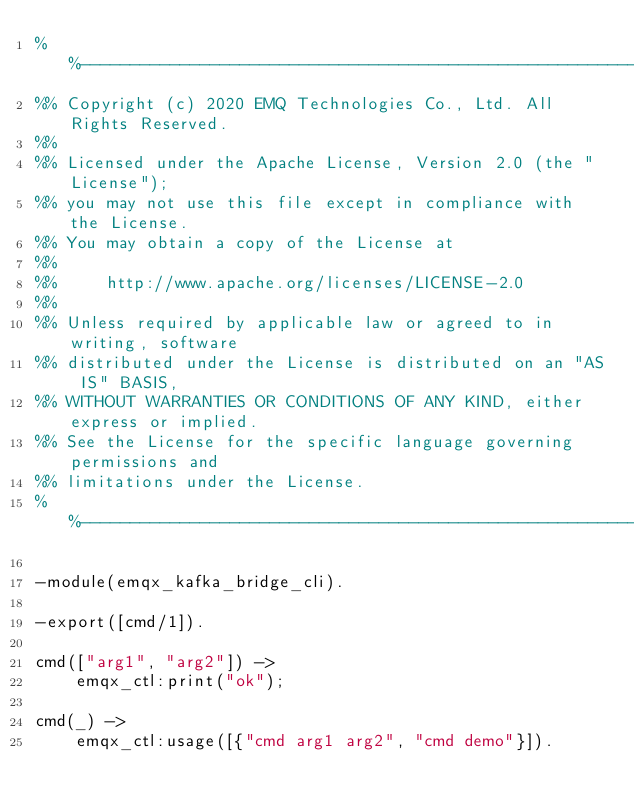<code> <loc_0><loc_0><loc_500><loc_500><_Erlang_>%%--------------------------------------------------------------------
%% Copyright (c) 2020 EMQ Technologies Co., Ltd. All Rights Reserved.
%%
%% Licensed under the Apache License, Version 2.0 (the "License");
%% you may not use this file except in compliance with the License.
%% You may obtain a copy of the License at
%%
%%     http://www.apache.org/licenses/LICENSE-2.0
%%
%% Unless required by applicable law or agreed to in writing, software
%% distributed under the License is distributed on an "AS IS" BASIS,
%% WITHOUT WARRANTIES OR CONDITIONS OF ANY KIND, either express or implied.
%% See the License for the specific language governing permissions and
%% limitations under the License.
%%--------------------------------------------------------------------

-module(emqx_kafka_bridge_cli).

-export([cmd/1]).

cmd(["arg1", "arg2"]) ->
    emqx_ctl:print("ok");

cmd(_) ->
    emqx_ctl:usage([{"cmd arg1 arg2", "cmd demo"}]).

</code> 